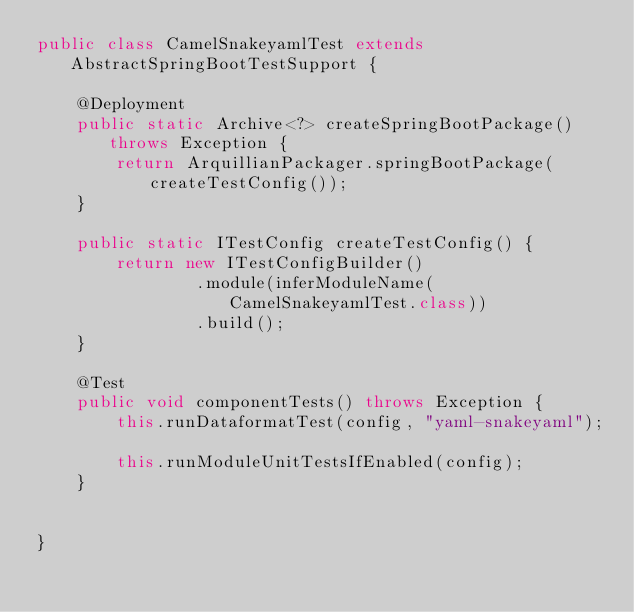<code> <loc_0><loc_0><loc_500><loc_500><_Java_>public class CamelSnakeyamlTest extends AbstractSpringBootTestSupport {

    @Deployment
    public static Archive<?> createSpringBootPackage() throws Exception {
        return ArquillianPackager.springBootPackage(createTestConfig());
    }

    public static ITestConfig createTestConfig() {
        return new ITestConfigBuilder()
                .module(inferModuleName(CamelSnakeyamlTest.class))
                .build();
    }

    @Test
    public void componentTests() throws Exception {
        this.runDataformatTest(config, "yaml-snakeyaml");

        this.runModuleUnitTestsIfEnabled(config);
    }


}
</code> 